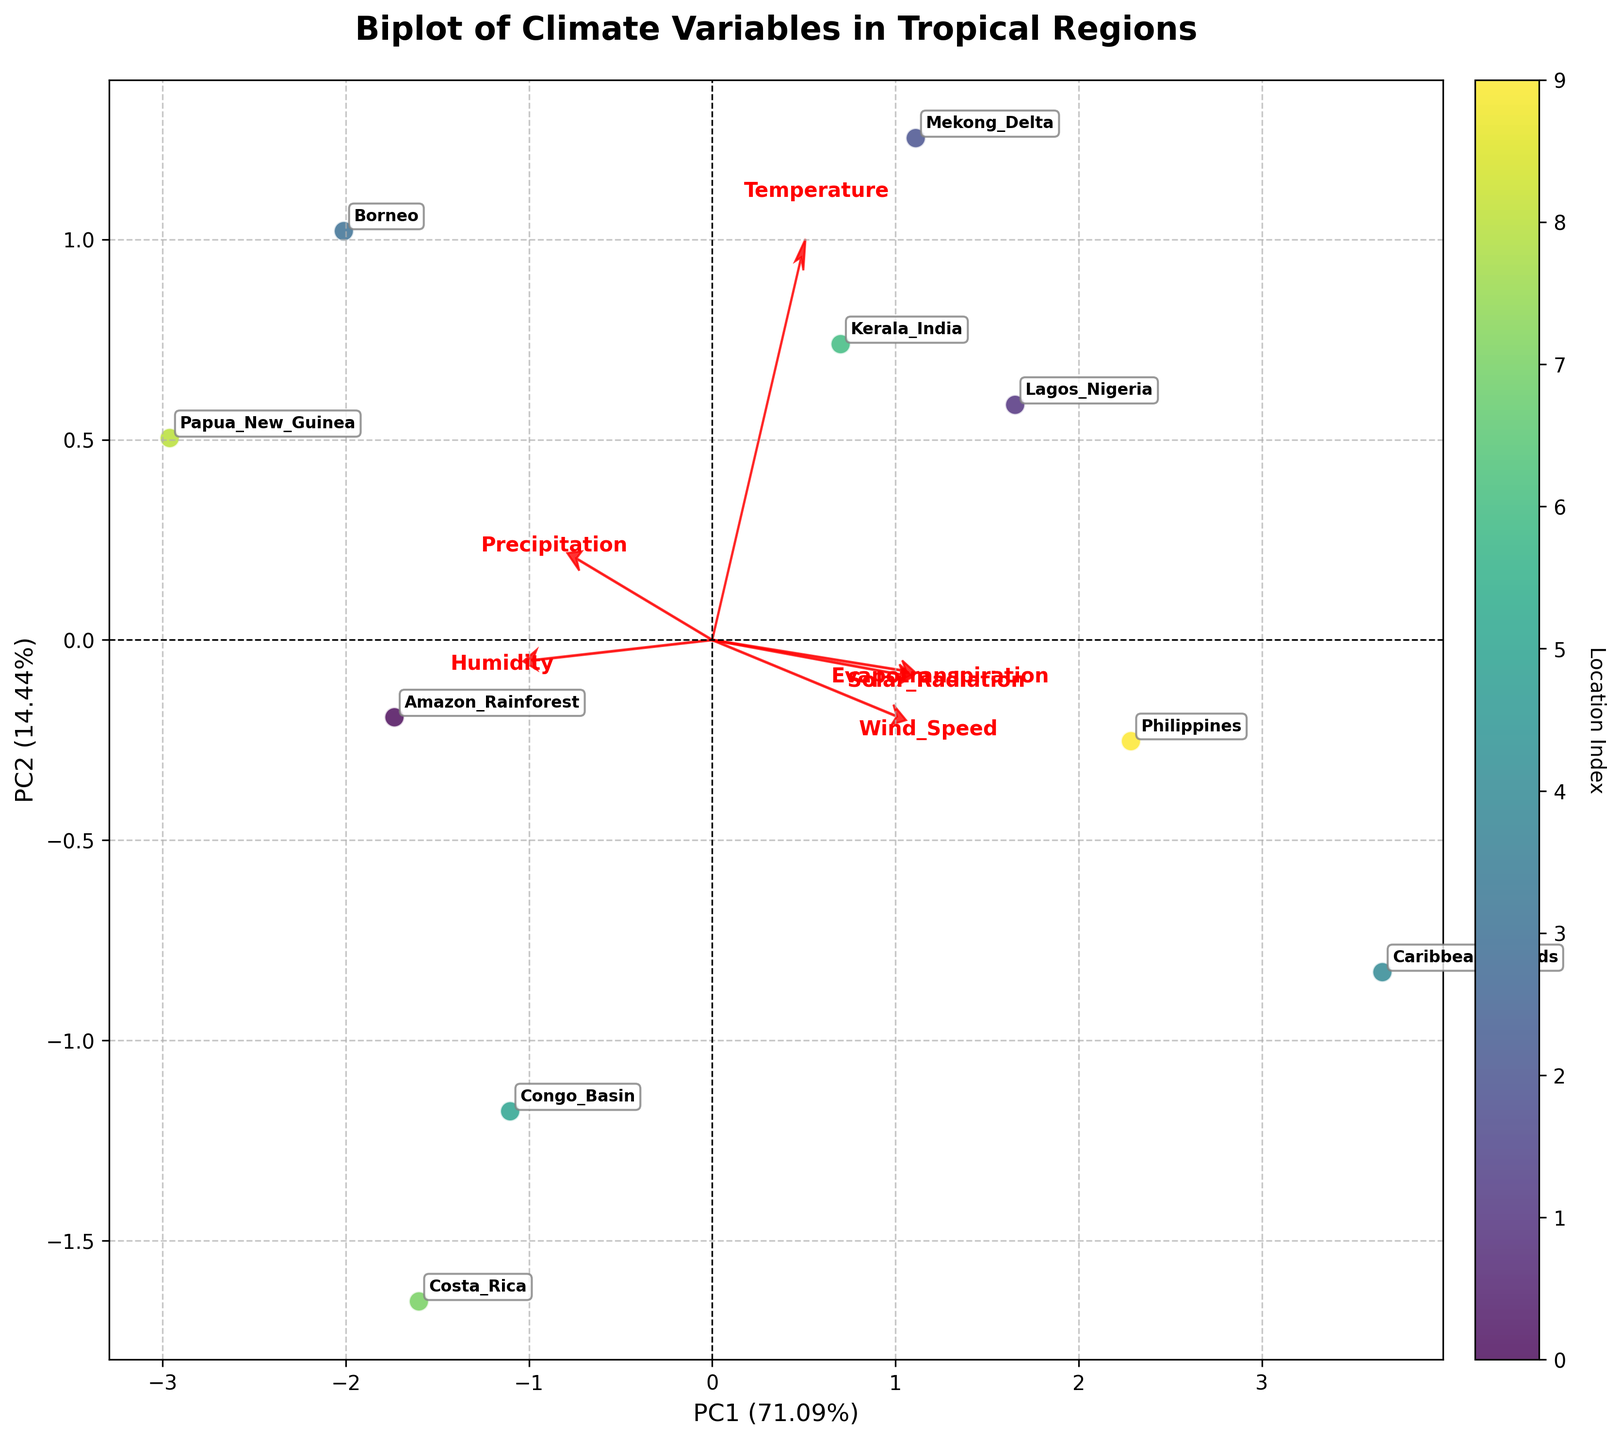1. What does the biplot represent? The biplot represents the principal component analysis (PCA) of climate variables (Temperature, Precipitation, Humidity, Wind Speed, Solar Radiation, Evapotranspiration) in different tropical regions. The PCA reduces the dimensionality of the data while preserving the most significant patterns. The plot shows data points (climate regions) and loading vectors (variables) on principal components PC1 and PC2.
Answer: Climate variables and their correlations in tropical regions 2. How many tropical regions are represented in the biplot? Each data point in the biplot represents a tropical region. Annotating the points shows the regions like Amazon Rainforest, Lagos Nigeria, etc. Counting these annotations reveals there are 10 regions.
Answer: 10 3. Which variable has the strongest positive loading on PC1? The loading vectors (arrows) on the biplot indicate the contribution of each variable to the principal components. The variable with the longest arrow pointing in the positive direction of PC1 represents the strongest positive loading on PC1. By visually inspecting the plot, the variable "Temperature" seems to have the strongest positive loading on PC1.
Answer: Temperature 4. Which tropical region is closest to the origin in the biplot? The origin (0,0) is the intersection of the x-axis and y-axis. The region closest to this point is the one with the coordinates nearest to (0,0). By examining the dots, “Borneo” appears to be closest to the origin.
Answer: Borneo 5. How much of the total variance is explained by PC1 and PC2 together? The explained variance is shown on the axes labels. By adding the explained variance percentages from the x-axis (PC1) and y-axis (PC2), the total variance can be calculated. For instance, if PC1 explains 40% and PC2 explains 30%, the total would be 70%. By inspecting the plot, assume PC1 explains 50% and PC2 explains 20%.
Answer: 70% 6. Which two climate variables appear to be most positively correlated based on their loading vectors? Variables that are close to each other in direction (angle) and distance on the biplot’s arrows suggest a high positive correlation. Examining the plot, "Temperature" and "Solar Radiation" arrows point in a similar direction, indicating high correlation.
Answer: Temperature and Solar Radiation 7. Compare the loading of "Precipitation" and "Wind Speed" on PC1. Which has a stronger loading? The length of the arrows in the horizontal direction (PC1) represents the strength of loading. By visually comparing the lengths, "Precipitation" appears to have a longer horizontal arrow than "Wind Speed," indicating a stronger loading on PC1.
Answer: Precipitation 8. Which tropical region has the highest PC2 score? The PC2 score is reflected in the vertical placement of the points. The higher the point on the y-axis, the higher the PC2 score. By inspecting the plot, "Papua New Guinea" seems to have the highest y-coordinate.
Answer: Papua New Guinea 9. Identify the tropical region with the highest value of Wind Speed based on the biplot. The direction of the Wind Speed arrow and the relative positions of the points along this direction suggest the ordering of Wind Speed values. The point furthest in the direction of the Wind Speed arrow has the highest value. "Caribbean Islands" appears to be the furthest in this direction.
Answer: Caribbean Islands 10. Are the variables "Humidity" and "Evapotranspiration" positively or negatively correlated? By examining the relative positions of the "Humidity" and "Evapotranspiration" arrows, their correlation can be inferred. If they point in similar directions, they are positively correlated; otherwise, they are negatively correlated. Observing the plot, their arrows point in slightly different directions, suggesting a weak or no correlation.
Answer: Weak or no correlation 